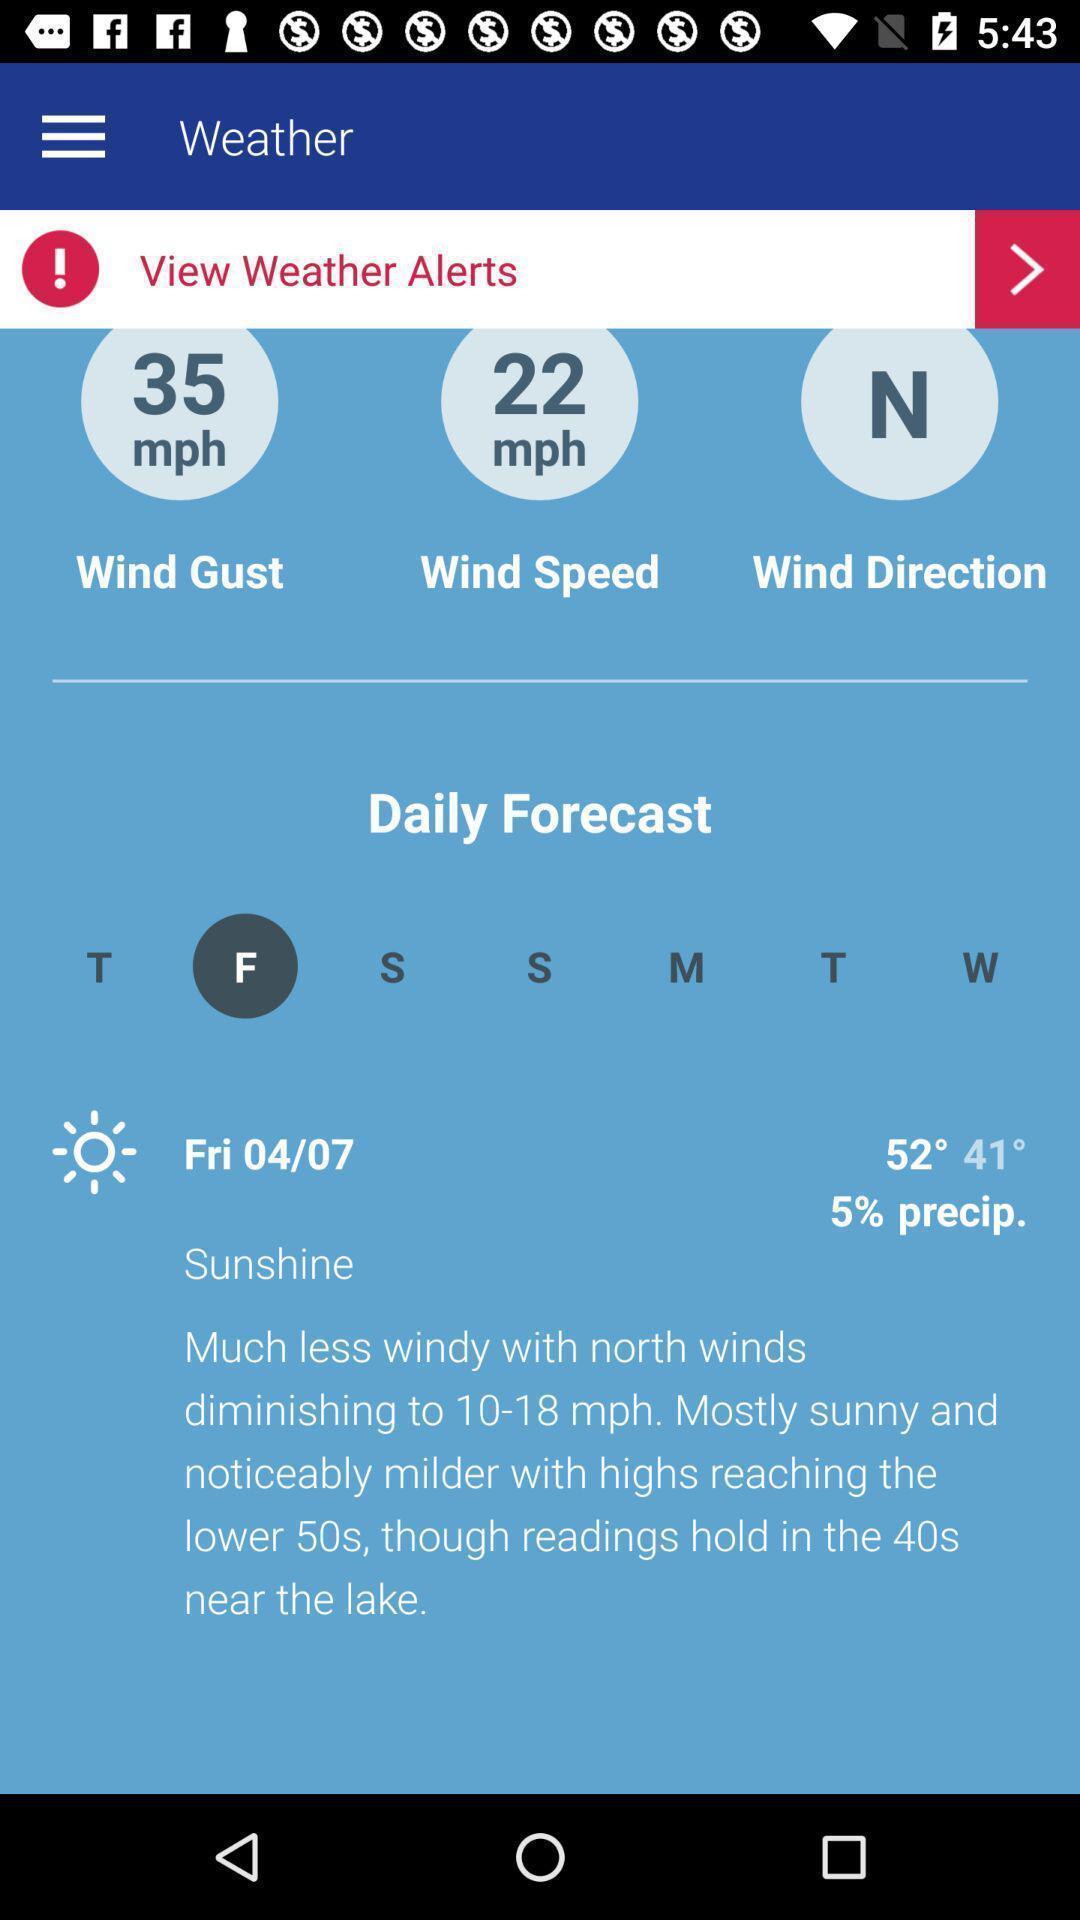Summarize the main components in this picture. Weather page in a local news app. 